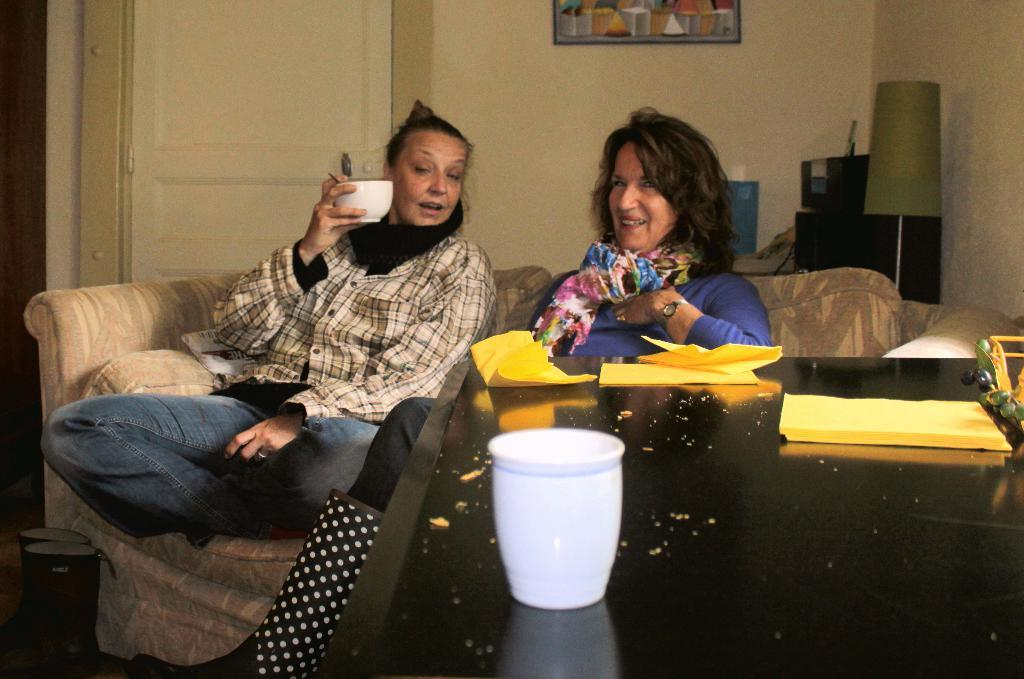How many people are in the image? There are two people in the image. What are the people doing in the image? The people are sitting on a sofa. What is in front of the sofa? There is a table in front of the sofa. What items can be seen on the table? There are papers and a glass on the table. What objects are located behind the table? There is a lamp and a photo frame behind the table. What type of chicken is being used to push the sofa in the image? There is no chicken or pushing action in the image; the people are simply sitting on the sofa. 